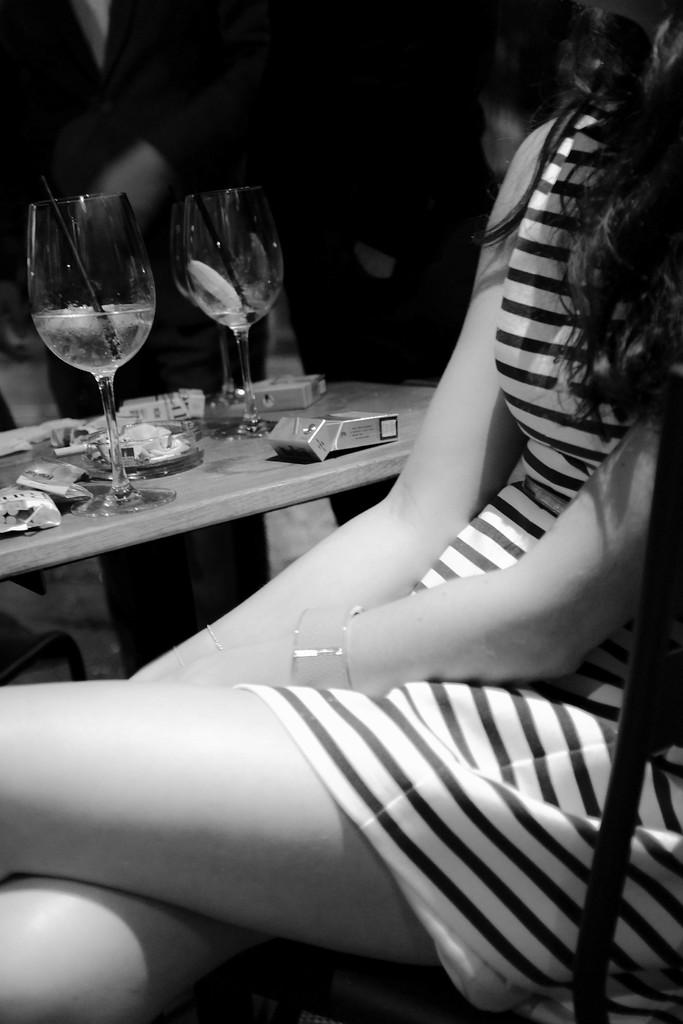What is the color scheme of the image? The image is black and white. What is the woman in the image doing? The woman is sitting on a chair in the image. What object is present in the image besides the woman and the chair? There is a table in the image. What items can be seen on the table? There are glasses on the table in the image. How many snails are crawling on the woman's chair in the image? There are no snails present in the image; it is a black and white image of a woman sitting on a chair with a table and glasses. 